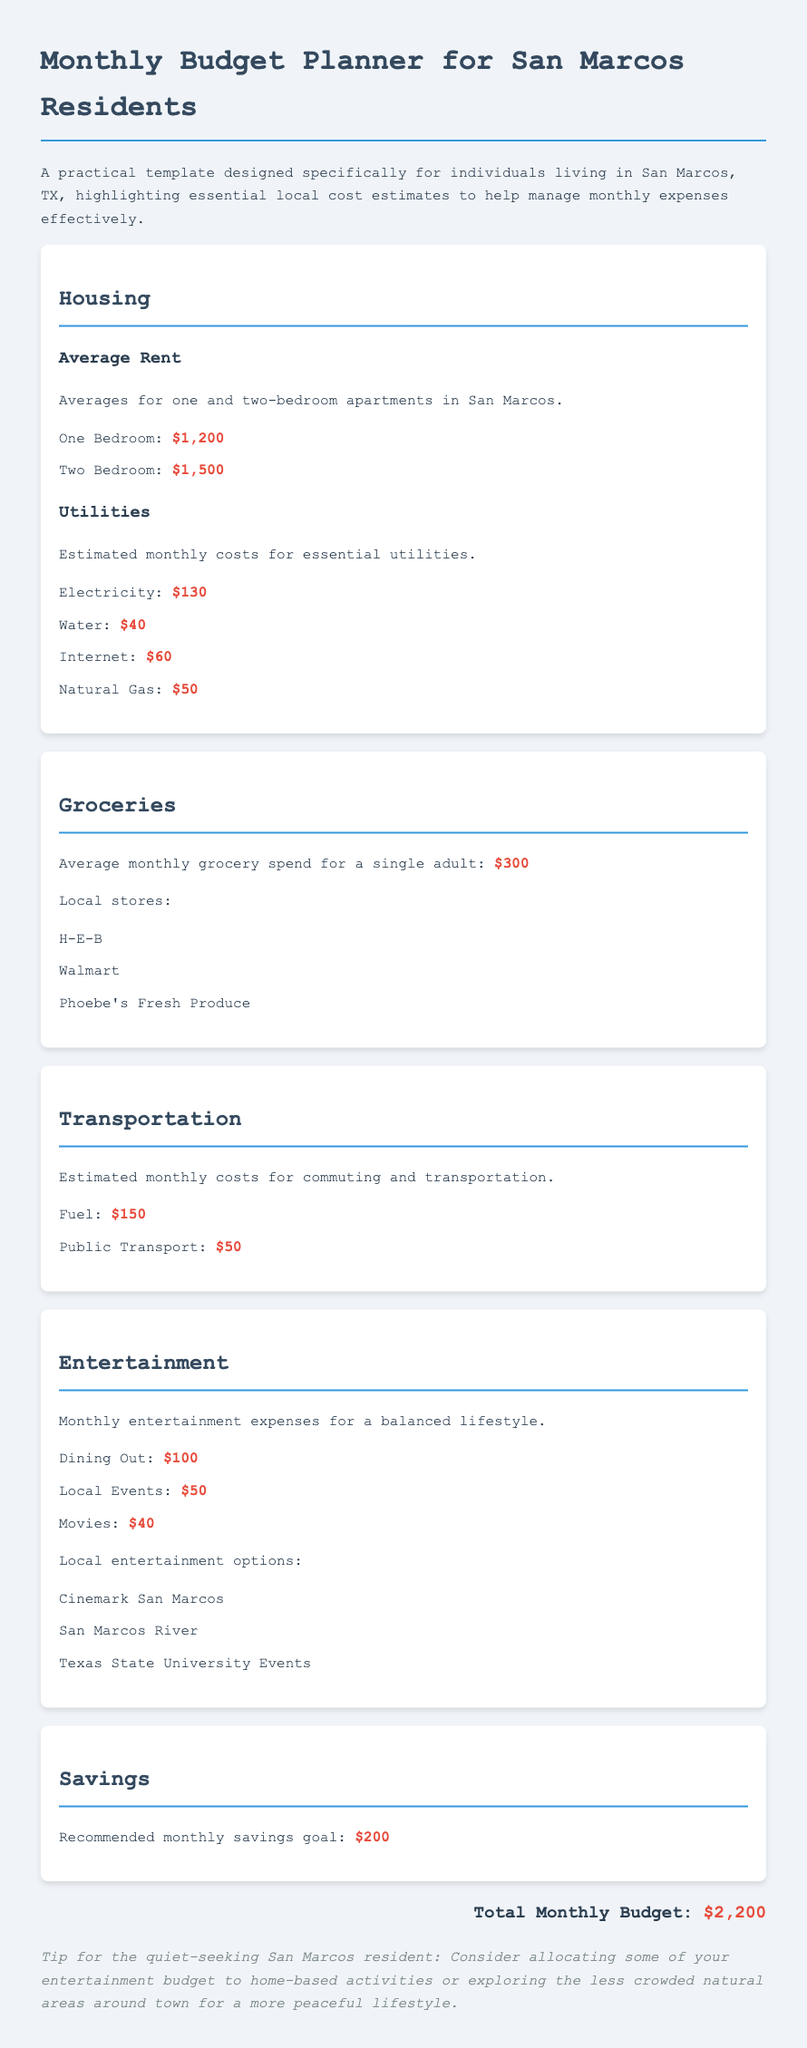What is the average rent for a one-bedroom apartment? The average rent for a one-bedroom apartment in San Marcos is provided in the housing section, which states it is $1,200.
Answer: $1,200 How much do utilities cost on average? The total estimated cost of utilities is the sum of all listed utilities, which equals $130 + $40 + $60 + $50 = $280.
Answer: $280 What is the average monthly grocery spend for a single adult? The document specifies the average monthly grocery spend for a single adult is $300.
Answer: $300 What is the recommended monthly savings goal? The document mentions the recommended monthly savings goal is $200.
Answer: $200 What is the total monthly budget? The total monthly budget shown at the end of the document sums housing, utilities, groceries, transportation, entertainment, and savings, totaling $2,200.
Answer: $2,200 What are three local grocery stores mentioned? The grocery section lists three local stores: H-E-B, Walmart, and Phoebe's Fresh Produce.
Answer: H-E-B, Walmart, Phoebe's Fresh Produce What is the cost estimate for dining out? The entertainment section provides a cost estimate for dining out, which is $100.
Answer: $100 What tip is provided for quiet-seeking residents? The tip mentions to consider home-based activities or exploring less crowded natural areas for a peaceful lifestyle.
Answer: Home-based activities or less crowded natural areas 